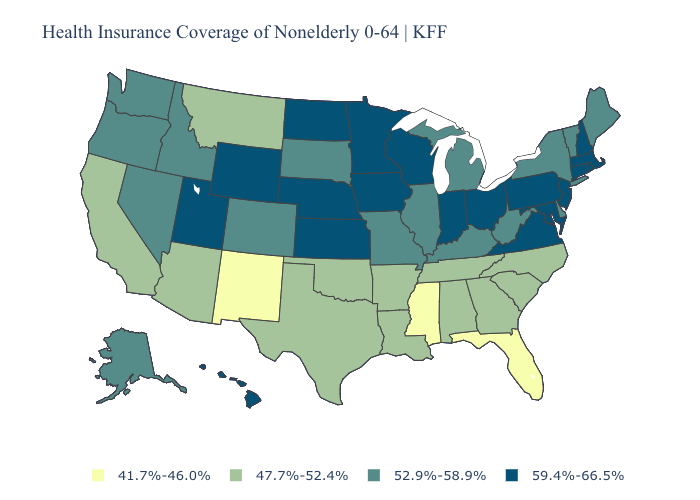Name the states that have a value in the range 59.4%-66.5%?
Answer briefly. Connecticut, Hawaii, Indiana, Iowa, Kansas, Maryland, Massachusetts, Minnesota, Nebraska, New Hampshire, New Jersey, North Dakota, Ohio, Pennsylvania, Rhode Island, Utah, Virginia, Wisconsin, Wyoming. Name the states that have a value in the range 52.9%-58.9%?
Be succinct. Alaska, Colorado, Delaware, Idaho, Illinois, Kentucky, Maine, Michigan, Missouri, Nevada, New York, Oregon, South Dakota, Vermont, Washington, West Virginia. Does Vermont have a higher value than North Dakota?
Concise answer only. No. What is the lowest value in the USA?
Short answer required. 41.7%-46.0%. Does the map have missing data?
Short answer required. No. Which states have the highest value in the USA?
Short answer required. Connecticut, Hawaii, Indiana, Iowa, Kansas, Maryland, Massachusetts, Minnesota, Nebraska, New Hampshire, New Jersey, North Dakota, Ohio, Pennsylvania, Rhode Island, Utah, Virginia, Wisconsin, Wyoming. Does Florida have the lowest value in the South?
Be succinct. Yes. Does New Mexico have the lowest value in the USA?
Short answer required. Yes. Name the states that have a value in the range 59.4%-66.5%?
Concise answer only. Connecticut, Hawaii, Indiana, Iowa, Kansas, Maryland, Massachusetts, Minnesota, Nebraska, New Hampshire, New Jersey, North Dakota, Ohio, Pennsylvania, Rhode Island, Utah, Virginia, Wisconsin, Wyoming. What is the value of Maine?
Short answer required. 52.9%-58.9%. What is the highest value in the Northeast ?
Give a very brief answer. 59.4%-66.5%. Does Mississippi have the lowest value in the South?
Short answer required. Yes. Name the states that have a value in the range 52.9%-58.9%?
Answer briefly. Alaska, Colorado, Delaware, Idaho, Illinois, Kentucky, Maine, Michigan, Missouri, Nevada, New York, Oregon, South Dakota, Vermont, Washington, West Virginia. Which states have the highest value in the USA?
Write a very short answer. Connecticut, Hawaii, Indiana, Iowa, Kansas, Maryland, Massachusetts, Minnesota, Nebraska, New Hampshire, New Jersey, North Dakota, Ohio, Pennsylvania, Rhode Island, Utah, Virginia, Wisconsin, Wyoming. Name the states that have a value in the range 41.7%-46.0%?
Concise answer only. Florida, Mississippi, New Mexico. 